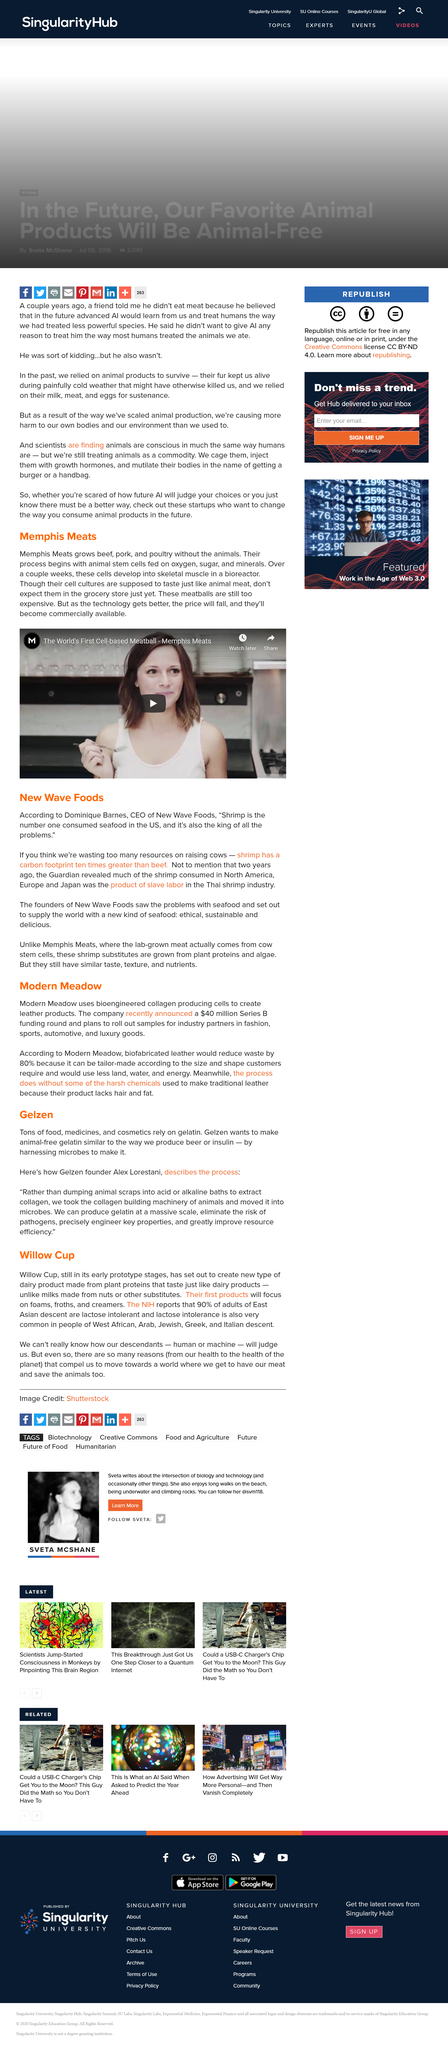Draw attention to some important aspects in this diagram. The cells develop into skeletal muscle in a bioreactor over a period of several weeks. Memphis Meats is dedicated to producing high-quality beef, pork, and poultry products without the use of live animals through innovative and sustainable methods. Willow Cup's dairy products are made from plant proteins instead of nuts or other substitutes. Shrimp is considered the king of all problems due to its high carbon footprint and contribution to slavery in the food industry. Willow Cup will initially produce foams, froths, and creamers, as well as other products that are currently in development. 